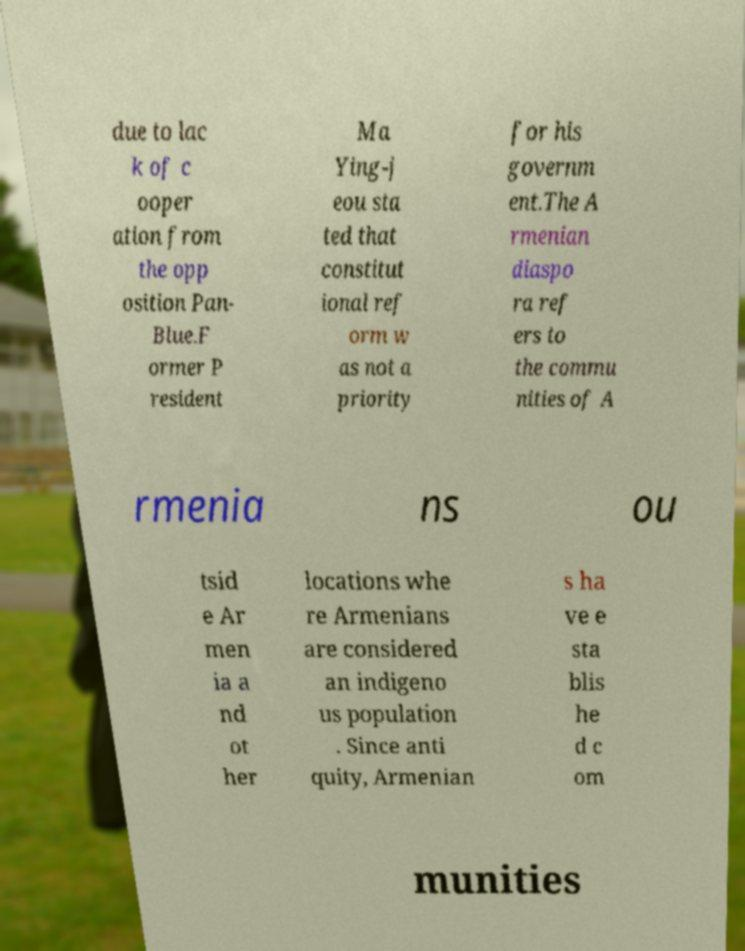Can you accurately transcribe the text from the provided image for me? due to lac k of c ooper ation from the opp osition Pan- Blue.F ormer P resident Ma Ying-j eou sta ted that constitut ional ref orm w as not a priority for his governm ent.The A rmenian diaspo ra ref ers to the commu nities of A rmenia ns ou tsid e Ar men ia a nd ot her locations whe re Armenians are considered an indigeno us population . Since anti quity, Armenian s ha ve e sta blis he d c om munities 